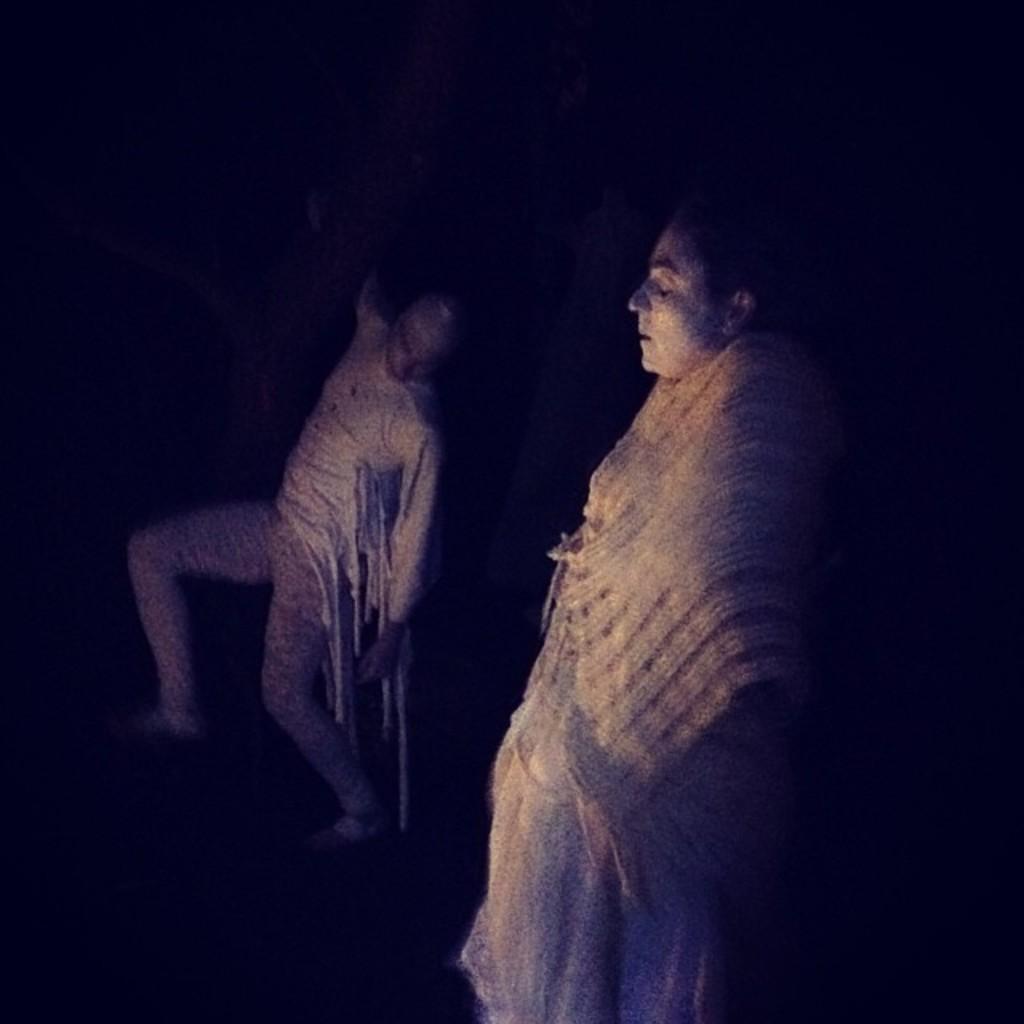Describe this image in one or two sentences. Here we can see two persons and there is a dark background. 